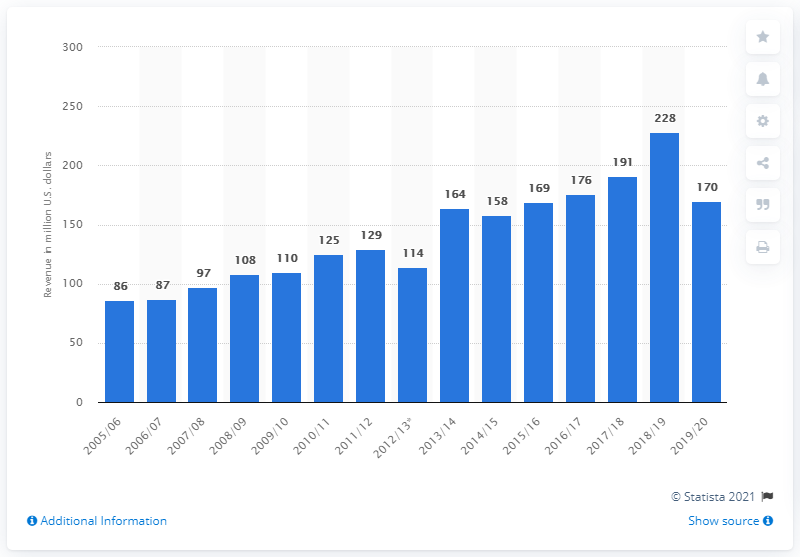Give some essential details in this illustration. The revenue of the Boston Bruins in the 2019/2020 season was approximately 170 million dollars. The last season of the Boston Bruins was in 2005/2006. In the 2019/2020 season, the Boston Bruins earned a total of 170 million dollars. 